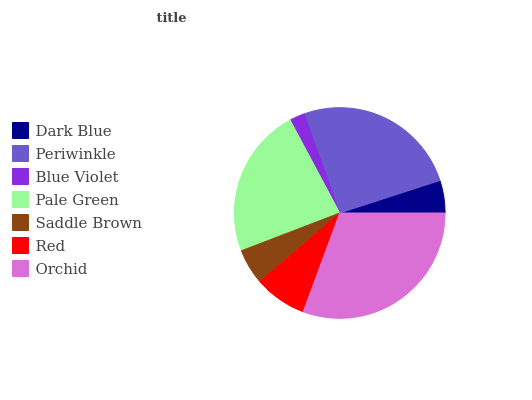Is Blue Violet the minimum?
Answer yes or no. Yes. Is Orchid the maximum?
Answer yes or no. Yes. Is Periwinkle the minimum?
Answer yes or no. No. Is Periwinkle the maximum?
Answer yes or no. No. Is Periwinkle greater than Dark Blue?
Answer yes or no. Yes. Is Dark Blue less than Periwinkle?
Answer yes or no. Yes. Is Dark Blue greater than Periwinkle?
Answer yes or no. No. Is Periwinkle less than Dark Blue?
Answer yes or no. No. Is Red the high median?
Answer yes or no. Yes. Is Red the low median?
Answer yes or no. Yes. Is Dark Blue the high median?
Answer yes or no. No. Is Pale Green the low median?
Answer yes or no. No. 